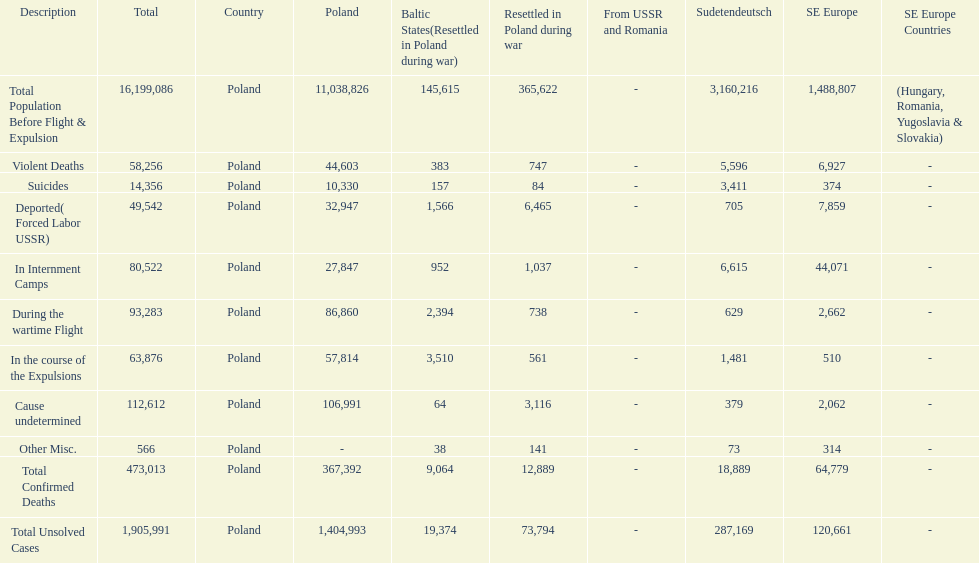What is the total of deaths in internment camps and during the wartime flight? 173,805. 